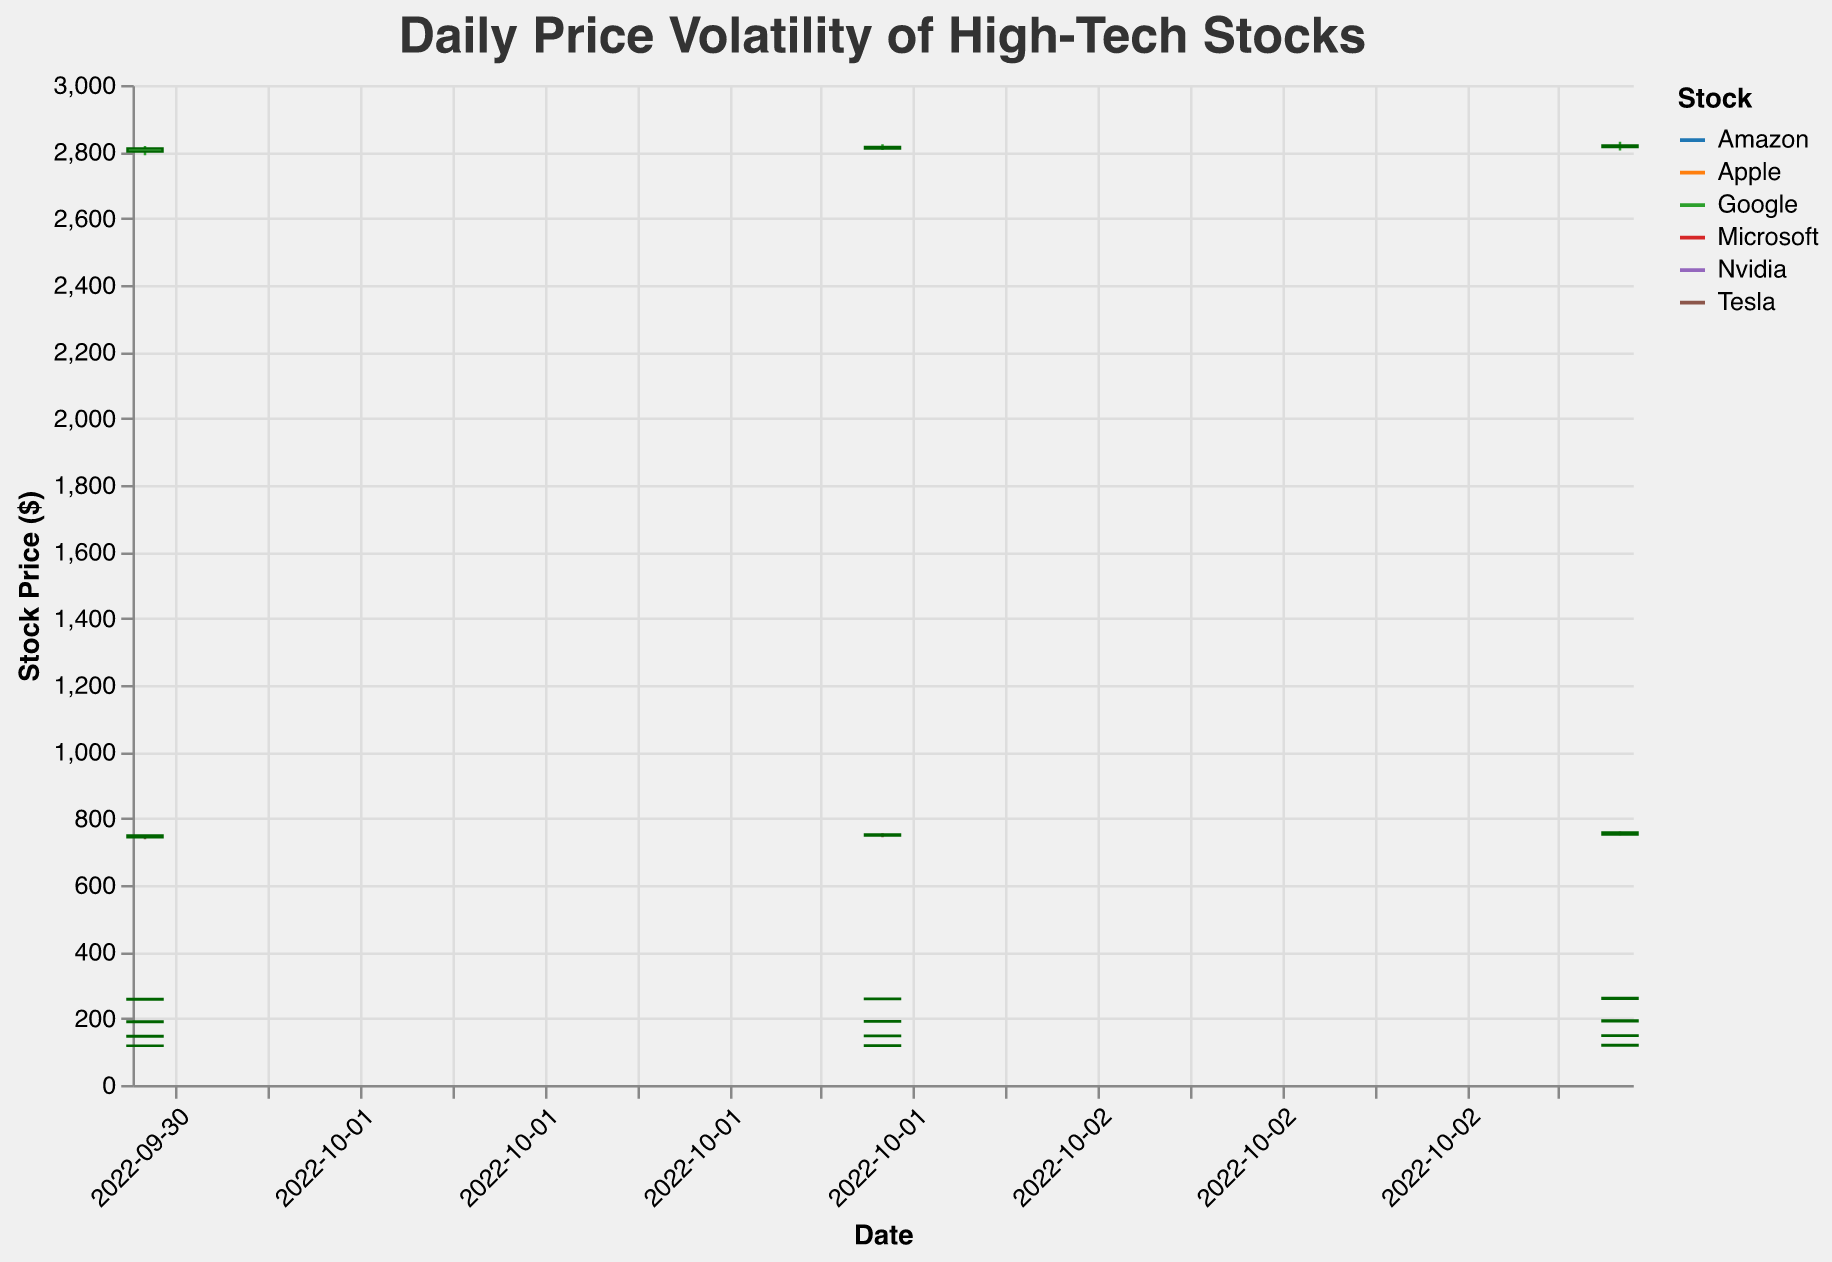What is the color used to differentiate the data for different stocks? The figure uses different colors to differentiate each stock, according to the legend and visual representation. For example, one line could be blue, another red, etc.
Answer: Various colors What is the range of dates displayed on the x-axis? The x-axis represents the date range from the start to the end of the provided data, which is from 2022-10-01 to 2022-10-03.
Answer: 2022-10-01 to 2022-10-03 Which stock had the highest closing price on October 3, 2022? By observing the candlestick for October 3, 2022, and comparing the closing prices of all stocks, Google had the highest closing price at 2818.71.
Answer: Google Which stock had the highest daily low price on October 2, 2022? By examining the ‘Low’ price for each stock on October 2, 2022, Google had the highest daily low price at 2804.71.
Answer: Google Which stock had the highest volume on October 1, 2022? By comparing the volume data for October 1, 2022, Amazon had the highest volume at 64251237.
Answer: Amazon Which stock showed the largest difference between its high and low prices on October 3, 2022? Calculate the difference between the high and low prices for each stock: Apple (149.44 - 146.96 = 2.48), Microsoft (261.44 - 258.12 = 3.32), Google (2829.98 - 2803.67 = 26.31), Amazon (120.11 - 118.02 = 2.09), Tesla (760.87 - 749.11 = 11.76), Nvidia (195.20 - 190.56 = 4.64). Google had the largest difference.
Answer: Google What is the median closing price of Apple over the three days? Arrange the closing prices for Apple (146.92, 147.91, 148.67) in ascending order. The median is the middle value: 147.91.
Answer: 147.91 Which stock had the most consecutive days where the closing price was higher than the opening price? Looking through the closing and opening prices, Amazon and Tesla both had three consecutive days where the closing price was higher than the opening price.
Answer: Amazon and Tesla Which stock has the smallest range between high and low prices on October 3, 2022? Calculate the difference between high and low prices for each stock on October 3, 2022: Apple (149.44 - 146.96 = 2.48), Microsoft (261.44 - 258.12 = 3.32), Google (2829.98 - 2803.67 = 26.31), Amazon (120.11 - 118.02 = 2.09), Tesla (760.87 - 749.11 = 11.76), Nvidia (195.20 - 190.56 = 4.64). Amazon has the smallest range.
Answer: Amazon 